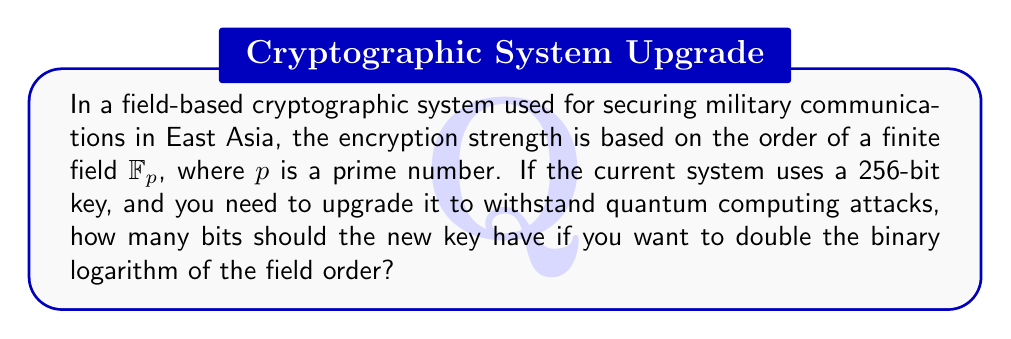Show me your answer to this math problem. Let's approach this step-by-step:

1) In a field-based cryptographic system, the key size is typically equal to the binary logarithm of the field order. So, for a 256-bit key:

   $\log_2(|\mathbb{F}_p|) = 256$

2) This means:

   $|\mathbb{F}_p| = 2^{256}$

3) To double the binary logarithm of the field order, we need:

   $\log_2(|\mathbb{F}_{\text{new}}|) = 2 \times 256 = 512$

4) This implies:

   $|\mathbb{F}_{\text{new}}| = 2^{512}$

5) The new key size will be equal to this new binary logarithm:

   New key size = 512 bits

Therefore, to double the binary logarithm of the field order and significantly increase the encryption strength against quantum computing attacks, the new key should be 512 bits.
Answer: 512 bits 